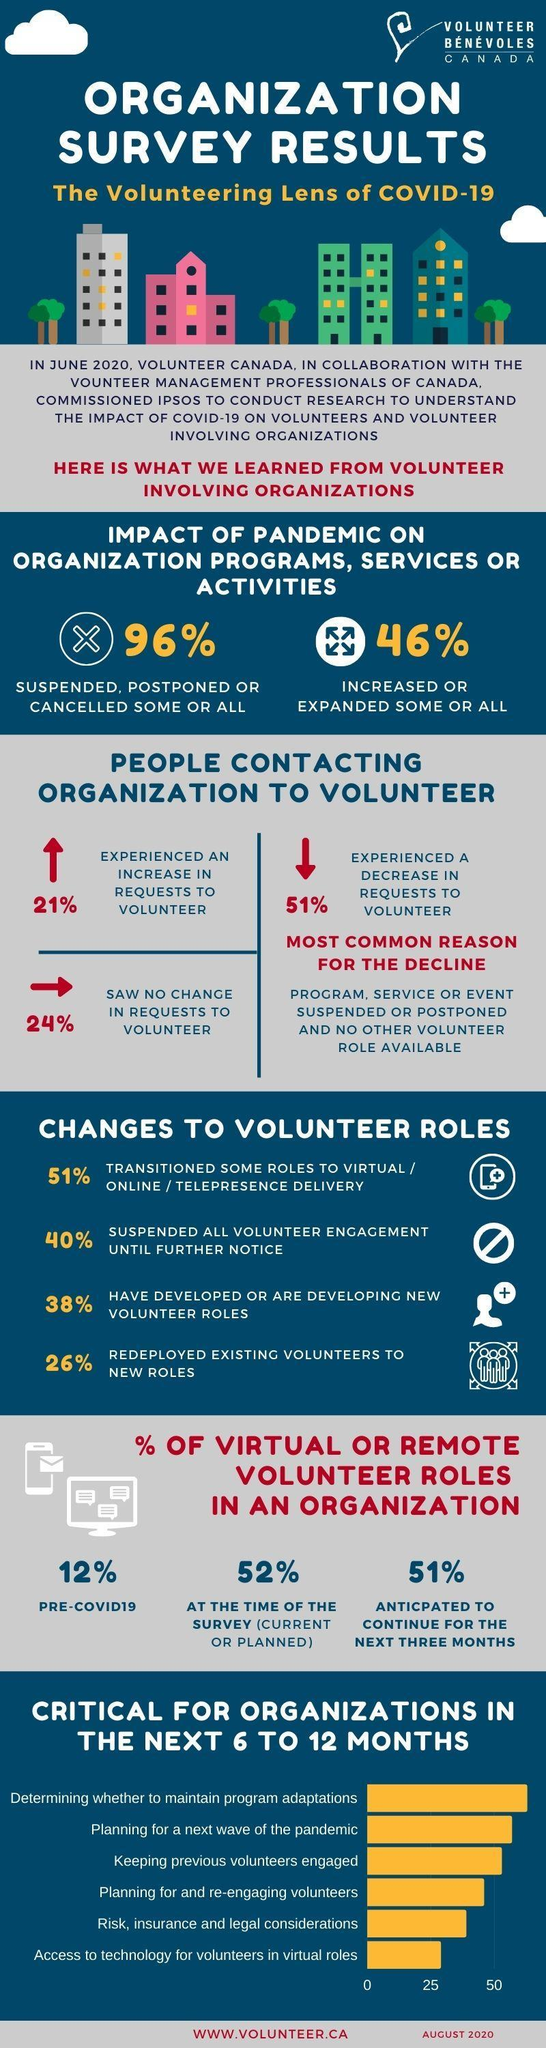What percentage of Volunteer organizations felt no issues in continuing their volunteering activities during pandemic?
Answer the question with a short phrase. 24% What is the inverse percentage of no of more requests to volunteer programs during pandemic? 79 How many points listed in the graph with heading "Critical for organizations" have crossed the 50 margin? 3 How many Volunteer organizations have stopped their entire activities till an announcement is made? 40% How many Volunteer organizations have already created or started thinking about fresh volunteer ideas? 38% What is the inverse of the no of virtually working volunteers before Covid-19? 88 How many Volunteer organizations have plans to continue their activities virtually for few more months? 51% How many Volunteer organizations have reassigned their workers for other positions? 26% How much decrease was there in the no of requests to volunteer during Covid-19? 51% What percentage of some or all volunteer organizations observed positive impact during COVID-19? 46% 